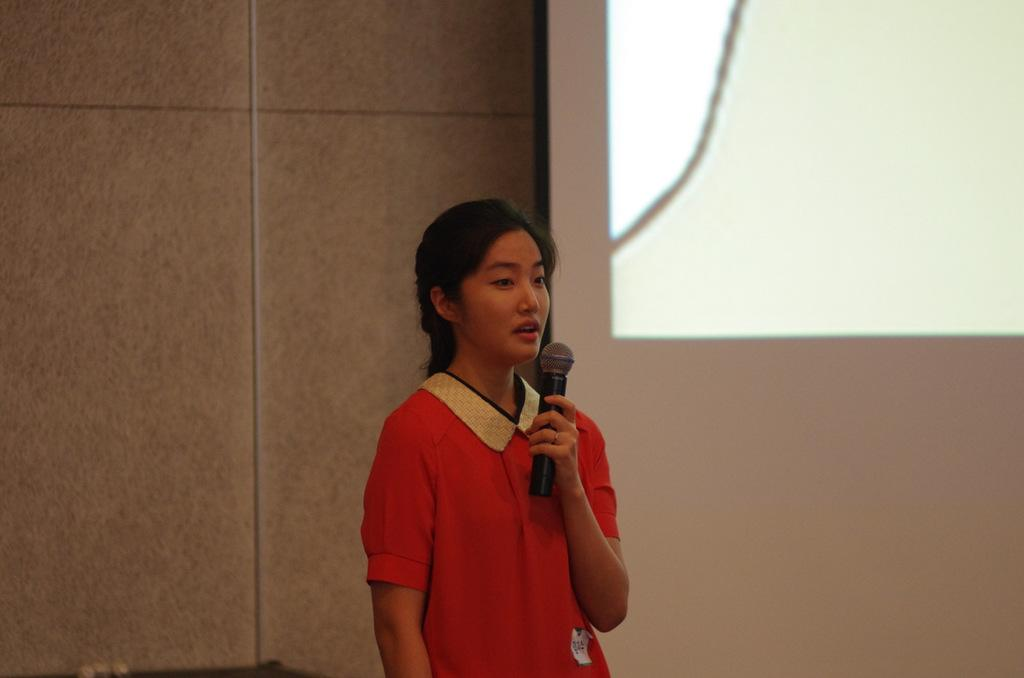Who is the main subject in the image? There is a woman in the image. What is the woman doing in the image? The woman is standing and speaking with the help of a microphone. What can be seen on the wall in the image? There is a projector light visible on the wall. What type of pan is being used by the woman in the image? There is no pan present in the image; the woman is using a microphone to speak. What is the woman cutting with the scissors in the image? There are no scissors present in the image; the woman is speaking with the help of a microphone. 